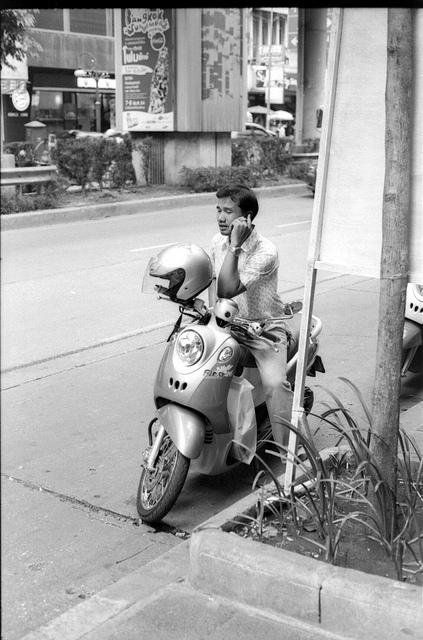What has the man stopped on his scooter? Please explain your reasoning. phone call. The man is holding a phone to their ear. 